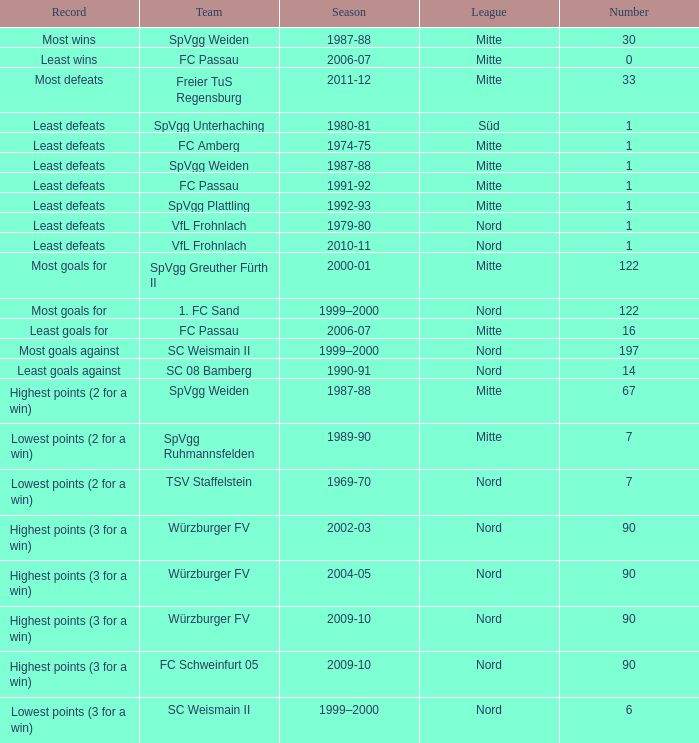What league has a number smaller than 1? Mitte. 